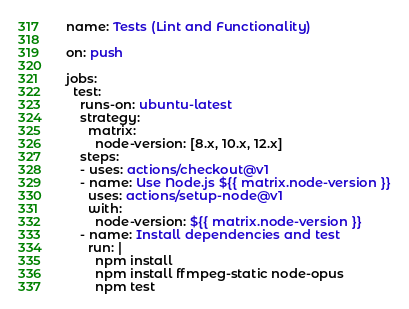Convert code to text. <code><loc_0><loc_0><loc_500><loc_500><_YAML_>name: Tests (Lint and Functionality)

on: push

jobs:
  test:
    runs-on: ubuntu-latest
    strategy:
      matrix:
        node-version: [8.x, 10.x, 12.x]
    steps:
    - uses: actions/checkout@v1
    - name: Use Node.js ${{ matrix.node-version }}
      uses: actions/setup-node@v1
      with:
        node-version: ${{ matrix.node-version }}
    - name: Install dependencies and test
      run: |
        npm install
        npm install ffmpeg-static node-opus
        npm test
</code> 